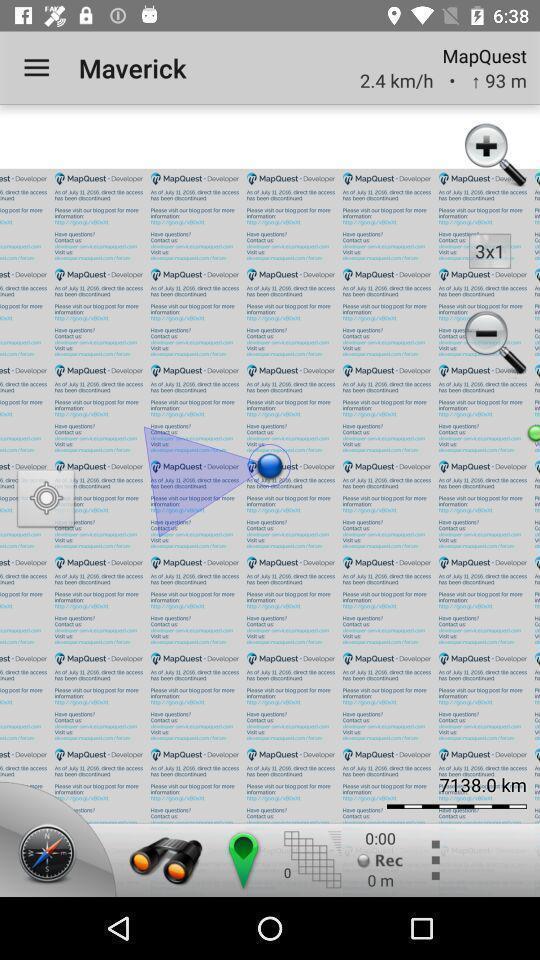Summarize the information in this screenshot. Screen shows different options in a navigator app. 